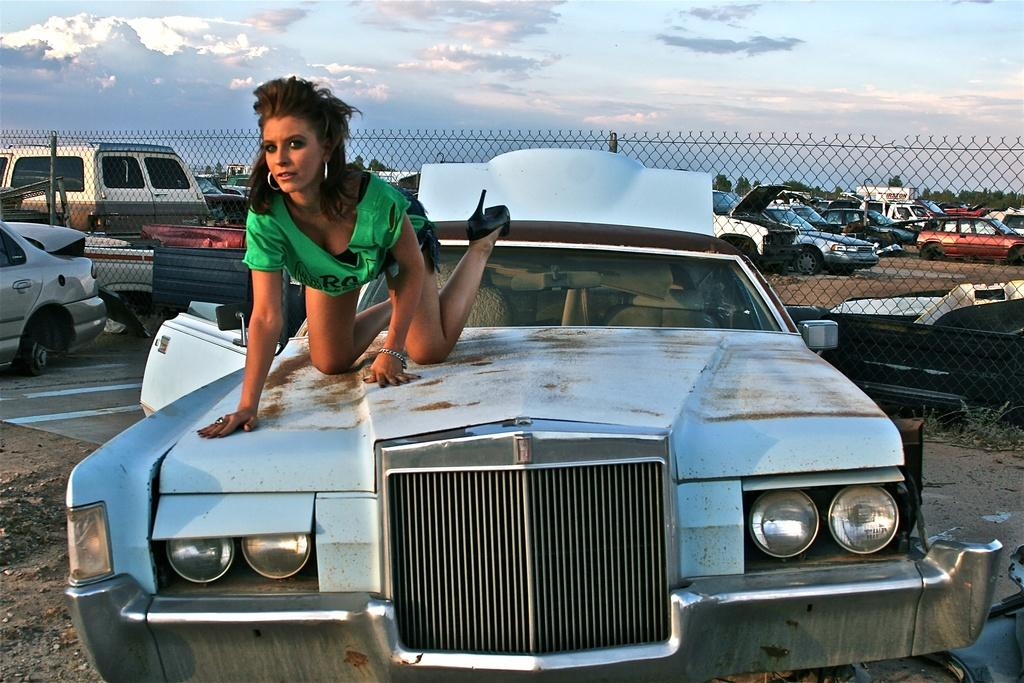What can be seen in the background of the image? In the background of the image, there is a sky with clouds, trees, vehicles, and a mesh. What is the woman in the image wearing? The woman in the image is wearing a t-shirt. Where is the woman located in the image? The woman is on a car in the image. What type of committee is meeting on the car in the image? There is no committee meeting on the car in the image; it is a woman standing on the car. Can you see the moon in the image? The moon is not visible in the image; only the sky with clouds is present. 